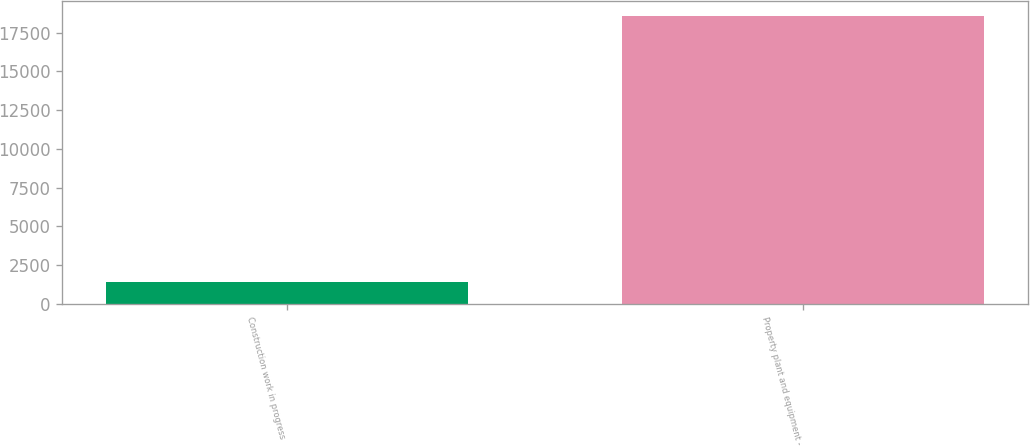Convert chart. <chart><loc_0><loc_0><loc_500><loc_500><bar_chart><fcel>Construction work in progress<fcel>Property plant and equipment -<nl><fcel>1441<fcel>18596<nl></chart> 